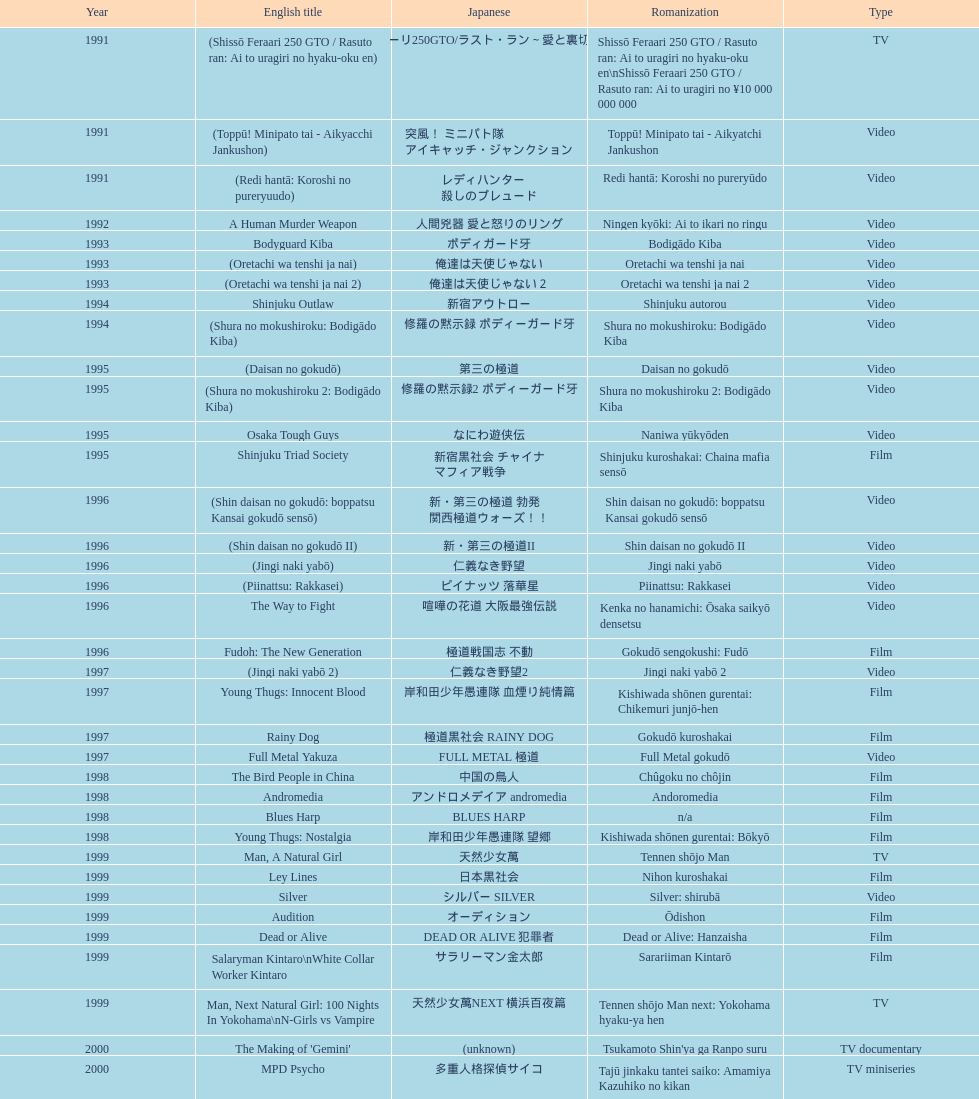Name a film that was released before 1996. Shinjuku Triad Society. 